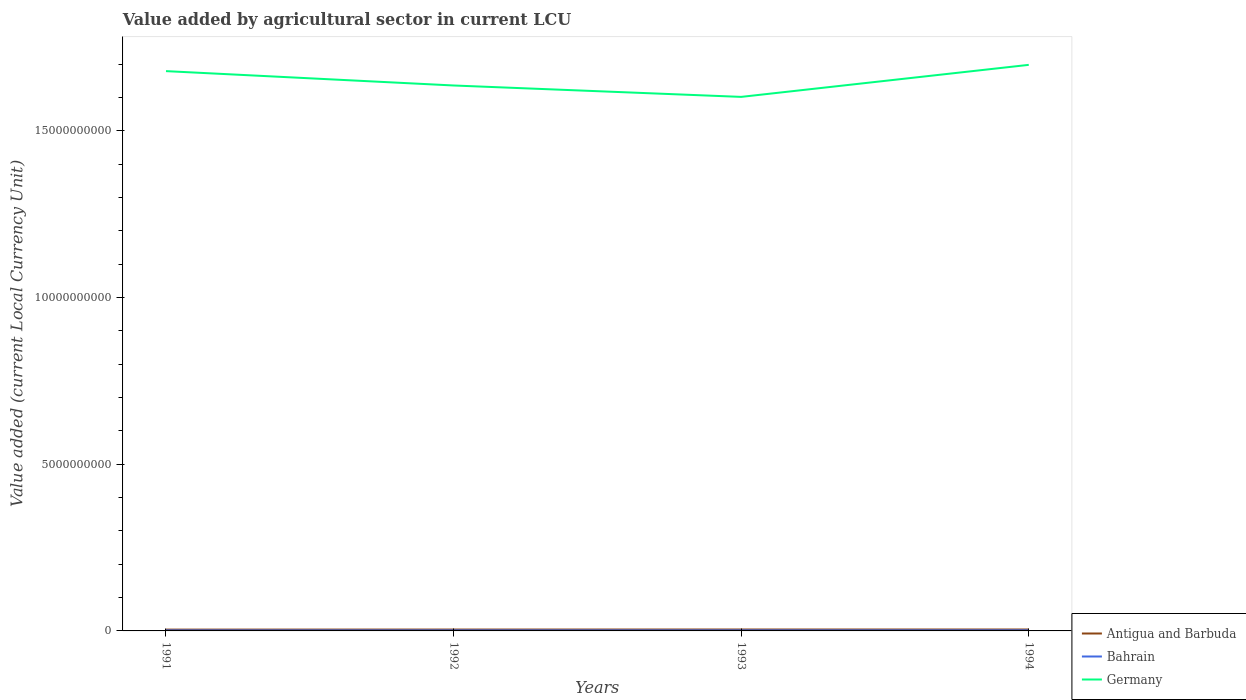How many different coloured lines are there?
Your answer should be very brief. 3. Across all years, what is the maximum value added by agricultural sector in Germany?
Your answer should be compact. 1.60e+1. What is the total value added by agricultural sector in Bahrain in the graph?
Ensure brevity in your answer.  -1.36e+06. What is the difference between the highest and the second highest value added by agricultural sector in Germany?
Provide a succinct answer. 9.61e+08. What is the difference between the highest and the lowest value added by agricultural sector in Germany?
Give a very brief answer. 2. Is the value added by agricultural sector in Germany strictly greater than the value added by agricultural sector in Bahrain over the years?
Keep it short and to the point. No. How many lines are there?
Ensure brevity in your answer.  3. Are the values on the major ticks of Y-axis written in scientific E-notation?
Provide a short and direct response. No. How are the legend labels stacked?
Your answer should be very brief. Vertical. What is the title of the graph?
Provide a succinct answer. Value added by agricultural sector in current LCU. Does "Kenya" appear as one of the legend labels in the graph?
Your response must be concise. No. What is the label or title of the Y-axis?
Ensure brevity in your answer.  Value added (current Local Currency Unit). What is the Value added (current Local Currency Unit) in Antigua and Barbuda in 1991?
Your answer should be compact. 3.92e+07. What is the Value added (current Local Currency Unit) of Bahrain in 1991?
Offer a very short reply. 1.53e+07. What is the Value added (current Local Currency Unit) of Germany in 1991?
Keep it short and to the point. 1.68e+1. What is the Value added (current Local Currency Unit) of Antigua and Barbuda in 1992?
Provide a short and direct response. 4.12e+07. What is the Value added (current Local Currency Unit) in Bahrain in 1992?
Make the answer very short. 1.63e+07. What is the Value added (current Local Currency Unit) of Germany in 1992?
Give a very brief answer. 1.64e+1. What is the Value added (current Local Currency Unit) in Antigua and Barbuda in 1993?
Keep it short and to the point. 4.28e+07. What is the Value added (current Local Currency Unit) of Bahrain in 1993?
Offer a terse response. 1.66e+07. What is the Value added (current Local Currency Unit) of Germany in 1993?
Your answer should be compact. 1.60e+1. What is the Value added (current Local Currency Unit) of Antigua and Barbuda in 1994?
Offer a very short reply. 4.26e+07. What is the Value added (current Local Currency Unit) in Bahrain in 1994?
Provide a succinct answer. 1.80e+07. What is the Value added (current Local Currency Unit) of Germany in 1994?
Provide a succinct answer. 1.70e+1. Across all years, what is the maximum Value added (current Local Currency Unit) in Antigua and Barbuda?
Provide a succinct answer. 4.28e+07. Across all years, what is the maximum Value added (current Local Currency Unit) in Bahrain?
Keep it short and to the point. 1.80e+07. Across all years, what is the maximum Value added (current Local Currency Unit) in Germany?
Keep it short and to the point. 1.70e+1. Across all years, what is the minimum Value added (current Local Currency Unit) in Antigua and Barbuda?
Give a very brief answer. 3.92e+07. Across all years, what is the minimum Value added (current Local Currency Unit) of Bahrain?
Offer a very short reply. 1.53e+07. Across all years, what is the minimum Value added (current Local Currency Unit) in Germany?
Offer a terse response. 1.60e+1. What is the total Value added (current Local Currency Unit) in Antigua and Barbuda in the graph?
Your answer should be very brief. 1.66e+08. What is the total Value added (current Local Currency Unit) in Bahrain in the graph?
Keep it short and to the point. 6.62e+07. What is the total Value added (current Local Currency Unit) in Germany in the graph?
Make the answer very short. 6.62e+1. What is the difference between the Value added (current Local Currency Unit) in Bahrain in 1991 and that in 1992?
Give a very brief answer. -9.43e+05. What is the difference between the Value added (current Local Currency Unit) in Germany in 1991 and that in 1992?
Your answer should be very brief. 4.31e+08. What is the difference between the Value added (current Local Currency Unit) of Antigua and Barbuda in 1991 and that in 1993?
Make the answer very short. -3.64e+06. What is the difference between the Value added (current Local Currency Unit) in Bahrain in 1991 and that in 1993?
Give a very brief answer. -1.34e+06. What is the difference between the Value added (current Local Currency Unit) of Germany in 1991 and that in 1993?
Your response must be concise. 7.73e+08. What is the difference between the Value added (current Local Currency Unit) of Antigua and Barbuda in 1991 and that in 1994?
Your response must be concise. -3.43e+06. What is the difference between the Value added (current Local Currency Unit) of Bahrain in 1991 and that in 1994?
Your answer should be compact. -2.70e+06. What is the difference between the Value added (current Local Currency Unit) of Germany in 1991 and that in 1994?
Offer a terse response. -1.88e+08. What is the difference between the Value added (current Local Currency Unit) of Antigua and Barbuda in 1992 and that in 1993?
Provide a short and direct response. -1.64e+06. What is the difference between the Value added (current Local Currency Unit) of Bahrain in 1992 and that in 1993?
Offer a very short reply. -3.93e+05. What is the difference between the Value added (current Local Currency Unit) in Germany in 1992 and that in 1993?
Make the answer very short. 3.42e+08. What is the difference between the Value added (current Local Currency Unit) of Antigua and Barbuda in 1992 and that in 1994?
Provide a short and direct response. -1.43e+06. What is the difference between the Value added (current Local Currency Unit) in Bahrain in 1992 and that in 1994?
Provide a short and direct response. -1.76e+06. What is the difference between the Value added (current Local Currency Unit) of Germany in 1992 and that in 1994?
Provide a succinct answer. -6.19e+08. What is the difference between the Value added (current Local Currency Unit) in Antigua and Barbuda in 1993 and that in 1994?
Keep it short and to the point. 2.10e+05. What is the difference between the Value added (current Local Currency Unit) of Bahrain in 1993 and that in 1994?
Offer a very short reply. -1.36e+06. What is the difference between the Value added (current Local Currency Unit) in Germany in 1993 and that in 1994?
Provide a succinct answer. -9.61e+08. What is the difference between the Value added (current Local Currency Unit) in Antigua and Barbuda in 1991 and the Value added (current Local Currency Unit) in Bahrain in 1992?
Give a very brief answer. 2.29e+07. What is the difference between the Value added (current Local Currency Unit) in Antigua and Barbuda in 1991 and the Value added (current Local Currency Unit) in Germany in 1992?
Provide a short and direct response. -1.63e+1. What is the difference between the Value added (current Local Currency Unit) in Bahrain in 1991 and the Value added (current Local Currency Unit) in Germany in 1992?
Provide a succinct answer. -1.63e+1. What is the difference between the Value added (current Local Currency Unit) of Antigua and Barbuda in 1991 and the Value added (current Local Currency Unit) of Bahrain in 1993?
Provide a succinct answer. 2.25e+07. What is the difference between the Value added (current Local Currency Unit) in Antigua and Barbuda in 1991 and the Value added (current Local Currency Unit) in Germany in 1993?
Offer a terse response. -1.60e+1. What is the difference between the Value added (current Local Currency Unit) in Bahrain in 1991 and the Value added (current Local Currency Unit) in Germany in 1993?
Give a very brief answer. -1.60e+1. What is the difference between the Value added (current Local Currency Unit) in Antigua and Barbuda in 1991 and the Value added (current Local Currency Unit) in Bahrain in 1994?
Your answer should be very brief. 2.12e+07. What is the difference between the Value added (current Local Currency Unit) in Antigua and Barbuda in 1991 and the Value added (current Local Currency Unit) in Germany in 1994?
Provide a short and direct response. -1.69e+1. What is the difference between the Value added (current Local Currency Unit) in Bahrain in 1991 and the Value added (current Local Currency Unit) in Germany in 1994?
Your answer should be very brief. -1.70e+1. What is the difference between the Value added (current Local Currency Unit) in Antigua and Barbuda in 1992 and the Value added (current Local Currency Unit) in Bahrain in 1993?
Your answer should be compact. 2.45e+07. What is the difference between the Value added (current Local Currency Unit) in Antigua and Barbuda in 1992 and the Value added (current Local Currency Unit) in Germany in 1993?
Keep it short and to the point. -1.60e+1. What is the difference between the Value added (current Local Currency Unit) in Bahrain in 1992 and the Value added (current Local Currency Unit) in Germany in 1993?
Give a very brief answer. -1.60e+1. What is the difference between the Value added (current Local Currency Unit) in Antigua and Barbuda in 1992 and the Value added (current Local Currency Unit) in Bahrain in 1994?
Provide a succinct answer. 2.32e+07. What is the difference between the Value added (current Local Currency Unit) of Antigua and Barbuda in 1992 and the Value added (current Local Currency Unit) of Germany in 1994?
Your answer should be very brief. -1.69e+1. What is the difference between the Value added (current Local Currency Unit) in Bahrain in 1992 and the Value added (current Local Currency Unit) in Germany in 1994?
Make the answer very short. -1.70e+1. What is the difference between the Value added (current Local Currency Unit) in Antigua and Barbuda in 1993 and the Value added (current Local Currency Unit) in Bahrain in 1994?
Provide a short and direct response. 2.48e+07. What is the difference between the Value added (current Local Currency Unit) in Antigua and Barbuda in 1993 and the Value added (current Local Currency Unit) in Germany in 1994?
Your response must be concise. -1.69e+1. What is the difference between the Value added (current Local Currency Unit) of Bahrain in 1993 and the Value added (current Local Currency Unit) of Germany in 1994?
Offer a terse response. -1.70e+1. What is the average Value added (current Local Currency Unit) in Antigua and Barbuda per year?
Keep it short and to the point. 4.15e+07. What is the average Value added (current Local Currency Unit) of Bahrain per year?
Provide a short and direct response. 1.66e+07. What is the average Value added (current Local Currency Unit) in Germany per year?
Offer a very short reply. 1.65e+1. In the year 1991, what is the difference between the Value added (current Local Currency Unit) in Antigua and Barbuda and Value added (current Local Currency Unit) in Bahrain?
Give a very brief answer. 2.39e+07. In the year 1991, what is the difference between the Value added (current Local Currency Unit) of Antigua and Barbuda and Value added (current Local Currency Unit) of Germany?
Your answer should be very brief. -1.68e+1. In the year 1991, what is the difference between the Value added (current Local Currency Unit) of Bahrain and Value added (current Local Currency Unit) of Germany?
Offer a terse response. -1.68e+1. In the year 1992, what is the difference between the Value added (current Local Currency Unit) in Antigua and Barbuda and Value added (current Local Currency Unit) in Bahrain?
Your answer should be compact. 2.49e+07. In the year 1992, what is the difference between the Value added (current Local Currency Unit) in Antigua and Barbuda and Value added (current Local Currency Unit) in Germany?
Provide a short and direct response. -1.63e+1. In the year 1992, what is the difference between the Value added (current Local Currency Unit) of Bahrain and Value added (current Local Currency Unit) of Germany?
Give a very brief answer. -1.63e+1. In the year 1993, what is the difference between the Value added (current Local Currency Unit) in Antigua and Barbuda and Value added (current Local Currency Unit) in Bahrain?
Offer a terse response. 2.62e+07. In the year 1993, what is the difference between the Value added (current Local Currency Unit) in Antigua and Barbuda and Value added (current Local Currency Unit) in Germany?
Offer a very short reply. -1.60e+1. In the year 1993, what is the difference between the Value added (current Local Currency Unit) of Bahrain and Value added (current Local Currency Unit) of Germany?
Provide a short and direct response. -1.60e+1. In the year 1994, what is the difference between the Value added (current Local Currency Unit) in Antigua and Barbuda and Value added (current Local Currency Unit) in Bahrain?
Keep it short and to the point. 2.46e+07. In the year 1994, what is the difference between the Value added (current Local Currency Unit) of Antigua and Barbuda and Value added (current Local Currency Unit) of Germany?
Provide a short and direct response. -1.69e+1. In the year 1994, what is the difference between the Value added (current Local Currency Unit) of Bahrain and Value added (current Local Currency Unit) of Germany?
Your response must be concise. -1.70e+1. What is the ratio of the Value added (current Local Currency Unit) of Antigua and Barbuda in 1991 to that in 1992?
Your answer should be compact. 0.95. What is the ratio of the Value added (current Local Currency Unit) in Bahrain in 1991 to that in 1992?
Ensure brevity in your answer.  0.94. What is the ratio of the Value added (current Local Currency Unit) in Germany in 1991 to that in 1992?
Keep it short and to the point. 1.03. What is the ratio of the Value added (current Local Currency Unit) of Antigua and Barbuda in 1991 to that in 1993?
Offer a very short reply. 0.92. What is the ratio of the Value added (current Local Currency Unit) in Bahrain in 1991 to that in 1993?
Provide a short and direct response. 0.92. What is the ratio of the Value added (current Local Currency Unit) in Germany in 1991 to that in 1993?
Provide a succinct answer. 1.05. What is the ratio of the Value added (current Local Currency Unit) of Antigua and Barbuda in 1991 to that in 1994?
Your response must be concise. 0.92. What is the ratio of the Value added (current Local Currency Unit) of Bahrain in 1991 to that in 1994?
Provide a short and direct response. 0.85. What is the ratio of the Value added (current Local Currency Unit) of Germany in 1991 to that in 1994?
Provide a short and direct response. 0.99. What is the ratio of the Value added (current Local Currency Unit) of Antigua and Barbuda in 1992 to that in 1993?
Offer a very short reply. 0.96. What is the ratio of the Value added (current Local Currency Unit) in Bahrain in 1992 to that in 1993?
Provide a short and direct response. 0.98. What is the ratio of the Value added (current Local Currency Unit) of Germany in 1992 to that in 1993?
Your answer should be compact. 1.02. What is the ratio of the Value added (current Local Currency Unit) of Antigua and Barbuda in 1992 to that in 1994?
Provide a succinct answer. 0.97. What is the ratio of the Value added (current Local Currency Unit) in Bahrain in 1992 to that in 1994?
Offer a terse response. 0.9. What is the ratio of the Value added (current Local Currency Unit) of Germany in 1992 to that in 1994?
Your answer should be compact. 0.96. What is the ratio of the Value added (current Local Currency Unit) in Antigua and Barbuda in 1993 to that in 1994?
Your answer should be very brief. 1. What is the ratio of the Value added (current Local Currency Unit) in Bahrain in 1993 to that in 1994?
Your answer should be very brief. 0.92. What is the ratio of the Value added (current Local Currency Unit) of Germany in 1993 to that in 1994?
Your response must be concise. 0.94. What is the difference between the highest and the second highest Value added (current Local Currency Unit) in Antigua and Barbuda?
Offer a terse response. 2.10e+05. What is the difference between the highest and the second highest Value added (current Local Currency Unit) in Bahrain?
Offer a terse response. 1.36e+06. What is the difference between the highest and the second highest Value added (current Local Currency Unit) in Germany?
Provide a succinct answer. 1.88e+08. What is the difference between the highest and the lowest Value added (current Local Currency Unit) in Antigua and Barbuda?
Give a very brief answer. 3.64e+06. What is the difference between the highest and the lowest Value added (current Local Currency Unit) in Bahrain?
Offer a terse response. 2.70e+06. What is the difference between the highest and the lowest Value added (current Local Currency Unit) in Germany?
Offer a very short reply. 9.61e+08. 